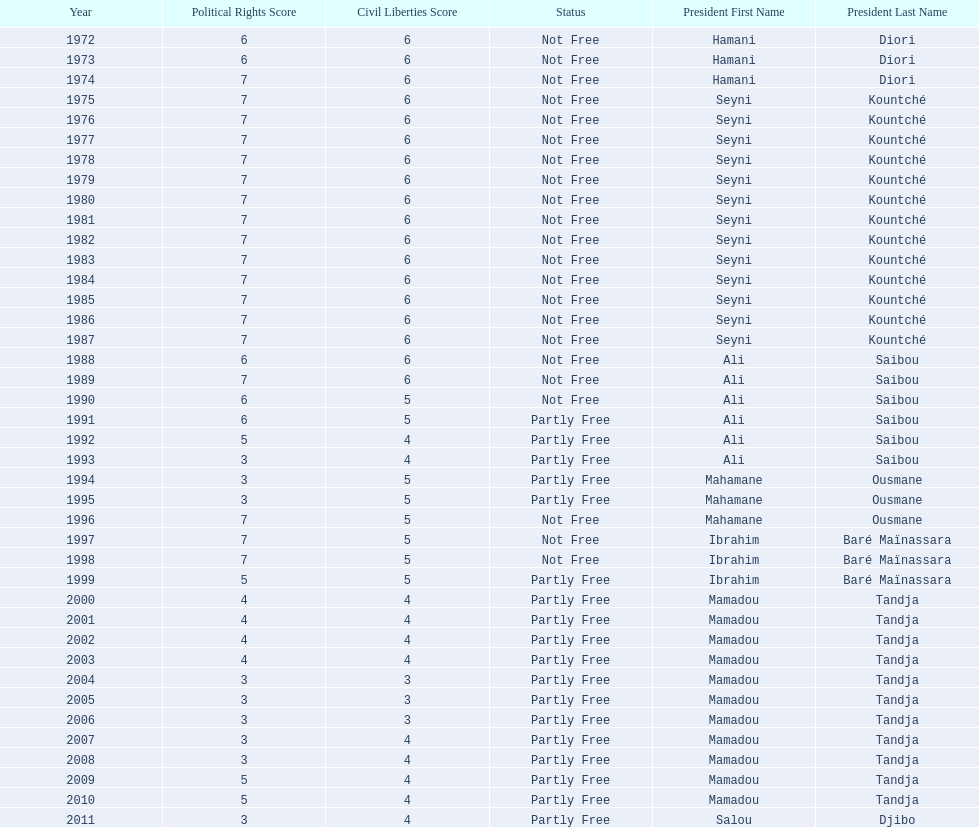How long did it take for civil liberties to decrease below 6? 18 years. 